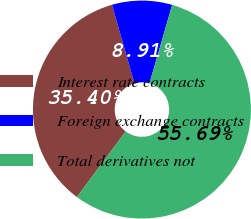Convert chart to OTSL. <chart><loc_0><loc_0><loc_500><loc_500><pie_chart><fcel>Interest rate contracts<fcel>Foreign exchange contracts<fcel>Total derivatives not<nl><fcel>35.4%<fcel>8.91%<fcel>55.7%<nl></chart> 